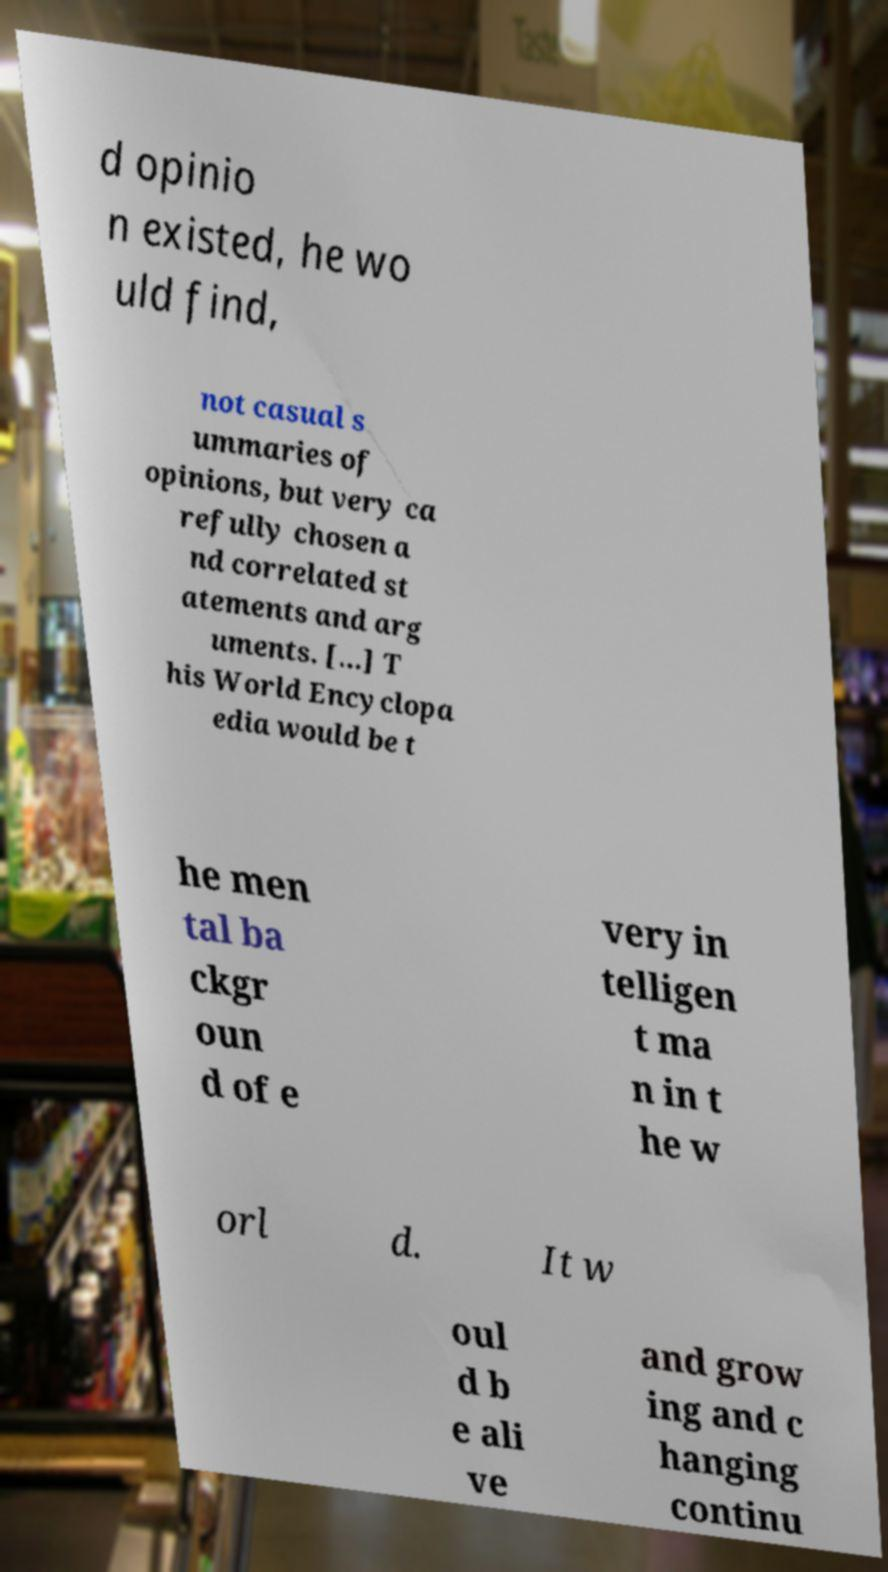I need the written content from this picture converted into text. Can you do that? d opinio n existed, he wo uld find, not casual s ummaries of opinions, but very ca refully chosen a nd correlated st atements and arg uments. [...] T his World Encyclopa edia would be t he men tal ba ckgr oun d of e very in telligen t ma n in t he w orl d. It w oul d b e ali ve and grow ing and c hanging continu 